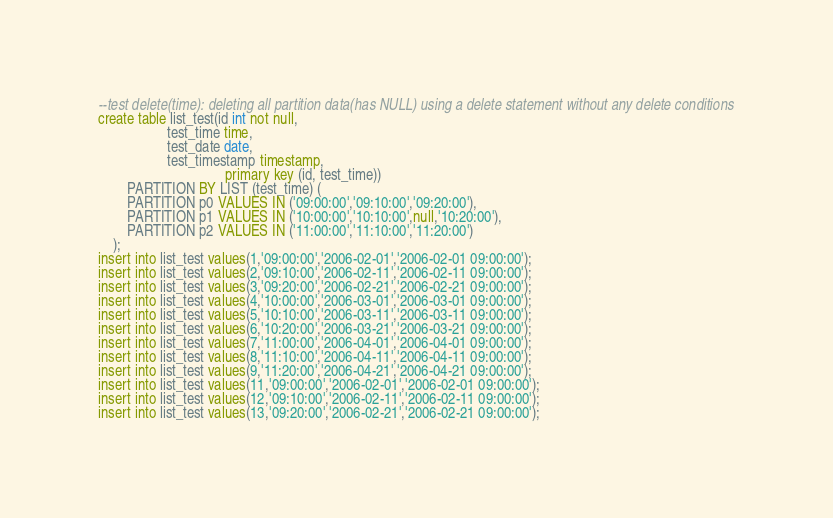<code> <loc_0><loc_0><loc_500><loc_500><_SQL_>--test delete(time): deleting all partition data(has NULL) using a delete statement without any delete conditions
create table list_test(id int not null,	
				   test_time time,
				   test_date date,
				   test_timestamp timestamp,
                                   primary key (id, test_time))
		PARTITION BY LIST (test_time) (
		PARTITION p0 VALUES IN ('09:00:00','09:10:00','09:20:00'),
		PARTITION p1 VALUES IN ('10:00:00','10:10:00',null,'10:20:00'),
		PARTITION p2 VALUES IN ('11:00:00','11:10:00','11:20:00')
	);
insert into list_test values(1,'09:00:00','2006-02-01','2006-02-01 09:00:00'); 
insert into list_test values(2,'09:10:00','2006-02-11','2006-02-11 09:00:00'); 
insert into list_test values(3,'09:20:00','2006-02-21','2006-02-21 09:00:00'); 
insert into list_test values(4,'10:00:00','2006-03-01','2006-03-01 09:00:00'); 
insert into list_test values(5,'10:10:00','2006-03-11','2006-03-11 09:00:00'); 
insert into list_test values(6,'10:20:00','2006-03-21','2006-03-21 09:00:00'); 
insert into list_test values(7,'11:00:00','2006-04-01','2006-04-01 09:00:00'); 
insert into list_test values(8,'11:10:00','2006-04-11','2006-04-11 09:00:00'); 
insert into list_test values(9,'11:20:00','2006-04-21','2006-04-21 09:00:00'); 
insert into list_test values(11,'09:00:00','2006-02-01','2006-02-01 09:00:00');
insert into list_test values(12,'09:10:00','2006-02-11','2006-02-11 09:00:00');
insert into list_test values(13,'09:20:00','2006-02-21','2006-02-21 09:00:00');</code> 